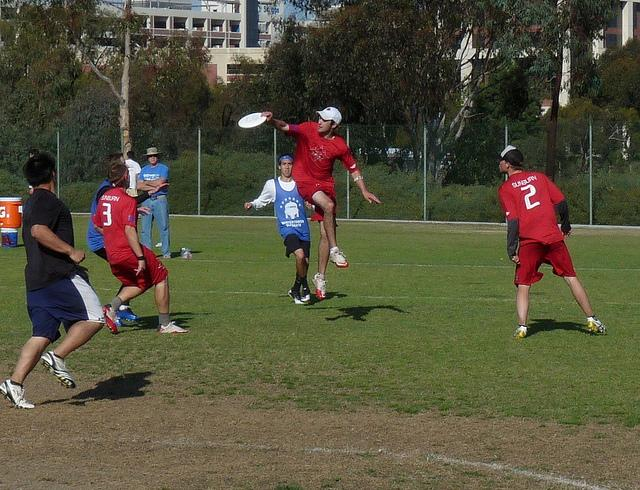What company has trademarked the popular name of this toy? wham-o 